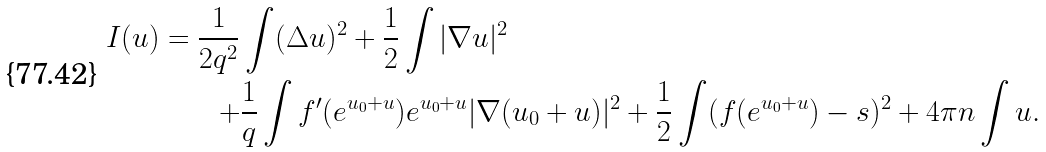Convert formula to latex. <formula><loc_0><loc_0><loc_500><loc_500>I ( u ) = \frac { 1 } { 2 q ^ { 2 } } & \int ( \Delta u ) ^ { 2 } + \frac { 1 } { 2 } \int | \nabla u | ^ { 2 } \\ + & \frac { 1 } { q } \int f ^ { \prime } ( e ^ { u _ { 0 } + u } ) e ^ { u _ { 0 } + u } | \nabla ( u _ { 0 } + u ) | ^ { 2 } + \frac { 1 } { 2 } \int ( f ( e ^ { u _ { 0 } + u } ) - s ) ^ { 2 } + 4 \pi n \int u .</formula> 